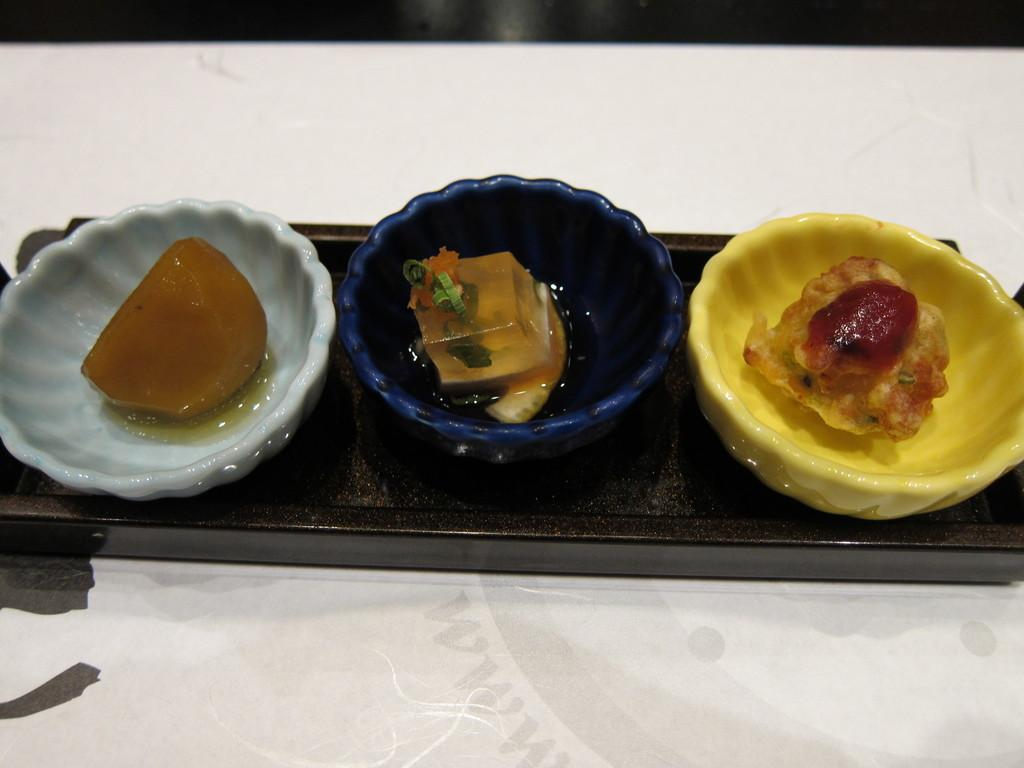What is the main subject of the image? The main subject of the image is three deserts in three different bowls. How are the deserts arranged in the image? The deserts are in three different bowls, which are in white, blue, and yellow colors. What is the color of the plate that holds the bowls? The plate is black in color. Where is the plate located in the image? The plate is on a table. How many oranges are being rubbed on the pump in the image? There are no oranges, rubbing, or pumps present in the image. 